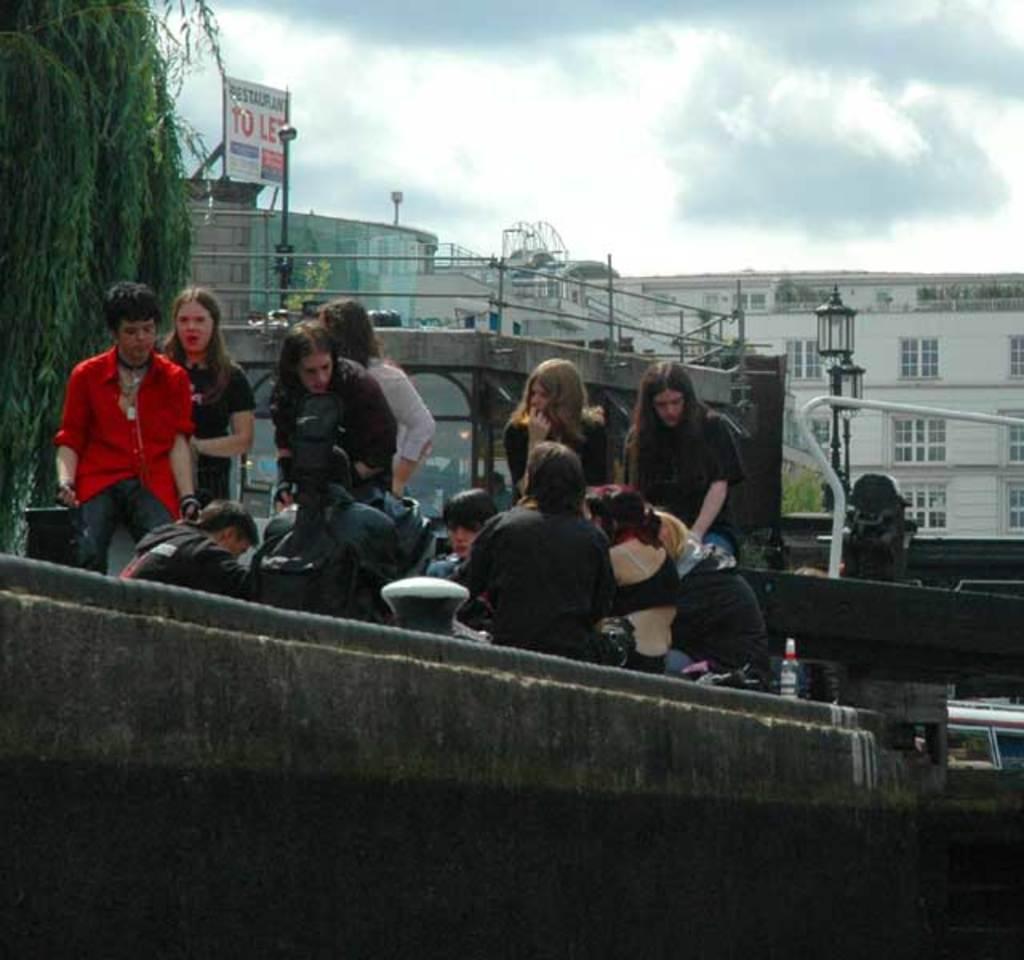In one or two sentences, can you explain what this image depicts? In the image I can see people among them some are standing and some are sitting. In the background I can see buildings, a board which has something written on it, street lights, poles, a bottle and some other objects. I can also see the sky. 